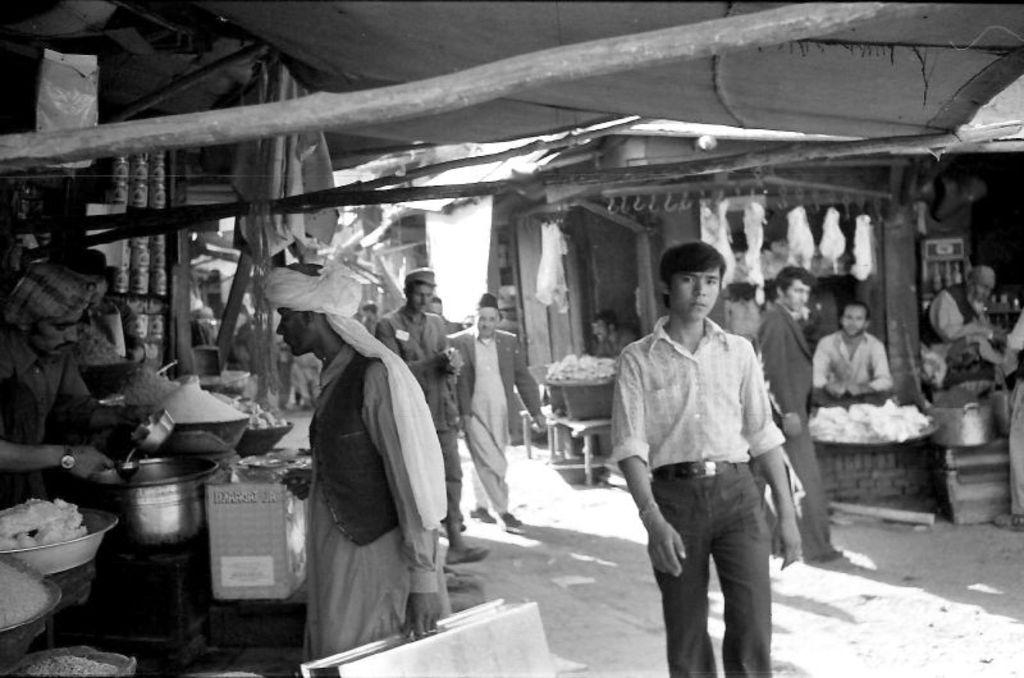What is the primary activity of the people in the image? The people in the image are on the ground, which suggests they might be sitting or standing. What can be seen in the bowls in the image? Food items are present in the image, and some of them are in bowls. What type of structure is visible in the image? There is a tent in the image. What objects can be seen in addition to the bowls and tent? Wooden poles are in the image, and there are other objects as well. What request does the daughter make in the image? There is no mention of a daughter or any request in the image. What is the position of the sun in the image? The provided facts do not mention the sun or its position in the image. 